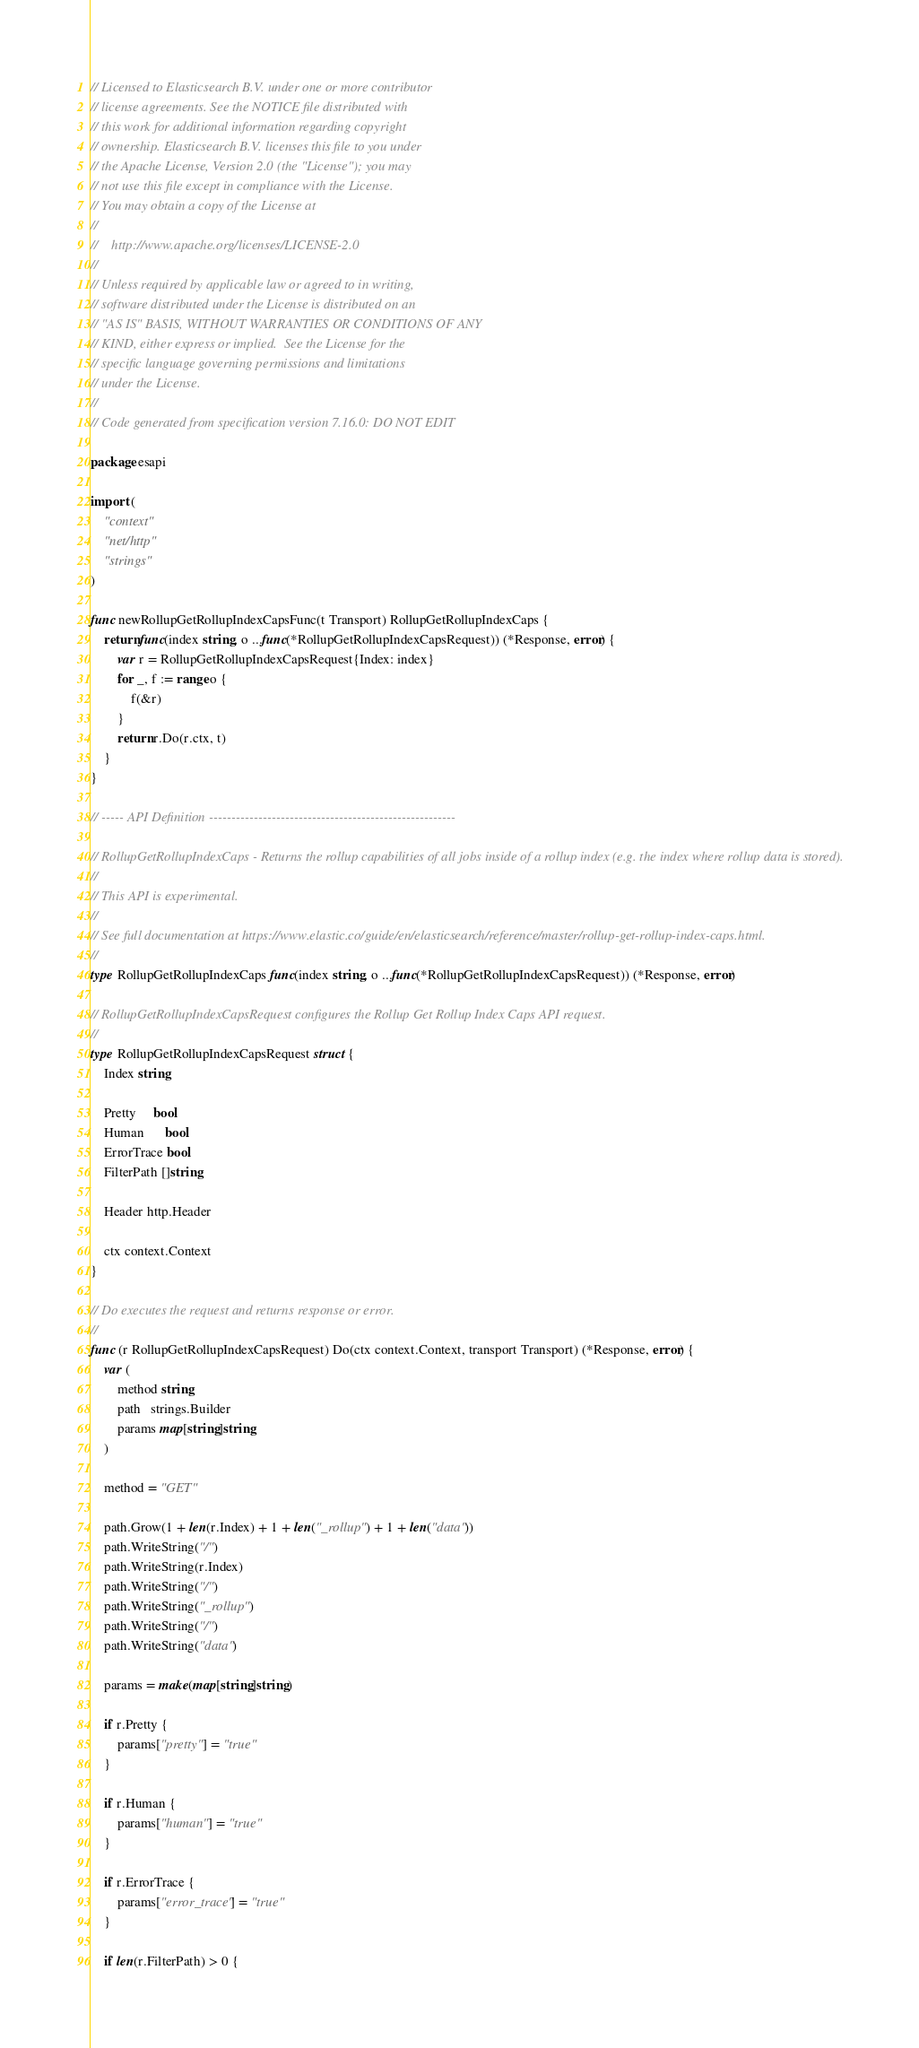<code> <loc_0><loc_0><loc_500><loc_500><_Go_>// Licensed to Elasticsearch B.V. under one or more contributor
// license agreements. See the NOTICE file distributed with
// this work for additional information regarding copyright
// ownership. Elasticsearch B.V. licenses this file to you under
// the Apache License, Version 2.0 (the "License"); you may
// not use this file except in compliance with the License.
// You may obtain a copy of the License at
//
//    http://www.apache.org/licenses/LICENSE-2.0
//
// Unless required by applicable law or agreed to in writing,
// software distributed under the License is distributed on an
// "AS IS" BASIS, WITHOUT WARRANTIES OR CONDITIONS OF ANY
// KIND, either express or implied.  See the License for the
// specific language governing permissions and limitations
// under the License.
//
// Code generated from specification version 7.16.0: DO NOT EDIT

package esapi

import (
	"context"
	"net/http"
	"strings"
)

func newRollupGetRollupIndexCapsFunc(t Transport) RollupGetRollupIndexCaps {
	return func(index string, o ...func(*RollupGetRollupIndexCapsRequest)) (*Response, error) {
		var r = RollupGetRollupIndexCapsRequest{Index: index}
		for _, f := range o {
			f(&r)
		}
		return r.Do(r.ctx, t)
	}
}

// ----- API Definition -------------------------------------------------------

// RollupGetRollupIndexCaps - Returns the rollup capabilities of all jobs inside of a rollup index (e.g. the index where rollup data is stored).
//
// This API is experimental.
//
// See full documentation at https://www.elastic.co/guide/en/elasticsearch/reference/master/rollup-get-rollup-index-caps.html.
//
type RollupGetRollupIndexCaps func(index string, o ...func(*RollupGetRollupIndexCapsRequest)) (*Response, error)

// RollupGetRollupIndexCapsRequest configures the Rollup Get Rollup Index Caps API request.
//
type RollupGetRollupIndexCapsRequest struct {
	Index string

	Pretty     bool
	Human      bool
	ErrorTrace bool
	FilterPath []string

	Header http.Header

	ctx context.Context
}

// Do executes the request and returns response or error.
//
func (r RollupGetRollupIndexCapsRequest) Do(ctx context.Context, transport Transport) (*Response, error) {
	var (
		method string
		path   strings.Builder
		params map[string]string
	)

	method = "GET"

	path.Grow(1 + len(r.Index) + 1 + len("_rollup") + 1 + len("data"))
	path.WriteString("/")
	path.WriteString(r.Index)
	path.WriteString("/")
	path.WriteString("_rollup")
	path.WriteString("/")
	path.WriteString("data")

	params = make(map[string]string)

	if r.Pretty {
		params["pretty"] = "true"
	}

	if r.Human {
		params["human"] = "true"
	}

	if r.ErrorTrace {
		params["error_trace"] = "true"
	}

	if len(r.FilterPath) > 0 {</code> 